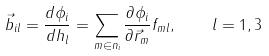Convert formula to latex. <formula><loc_0><loc_0><loc_500><loc_500>\vec { b } _ { i l } = \frac { d \phi _ { i } } { d h _ { l } } = \sum _ { m \in { n } _ { i } } \frac { \partial \phi _ { i } } { \partial \vec { r } _ { m } } f _ { m l } , \quad l = 1 , 3</formula> 